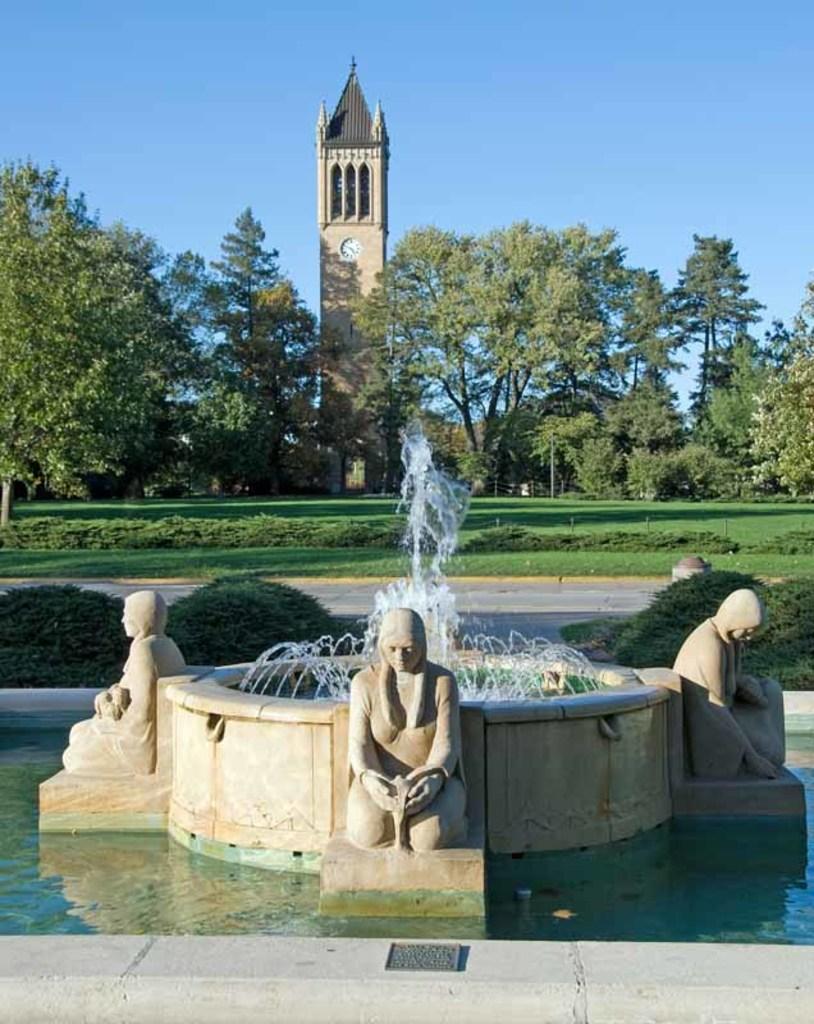Describe this image in one or two sentences. In this image, we can see a water fountain with few statues. Background we can see few plants, grass, trees. Here there is a clock tower with pillars and wall. Top of the image, there is a sky. 